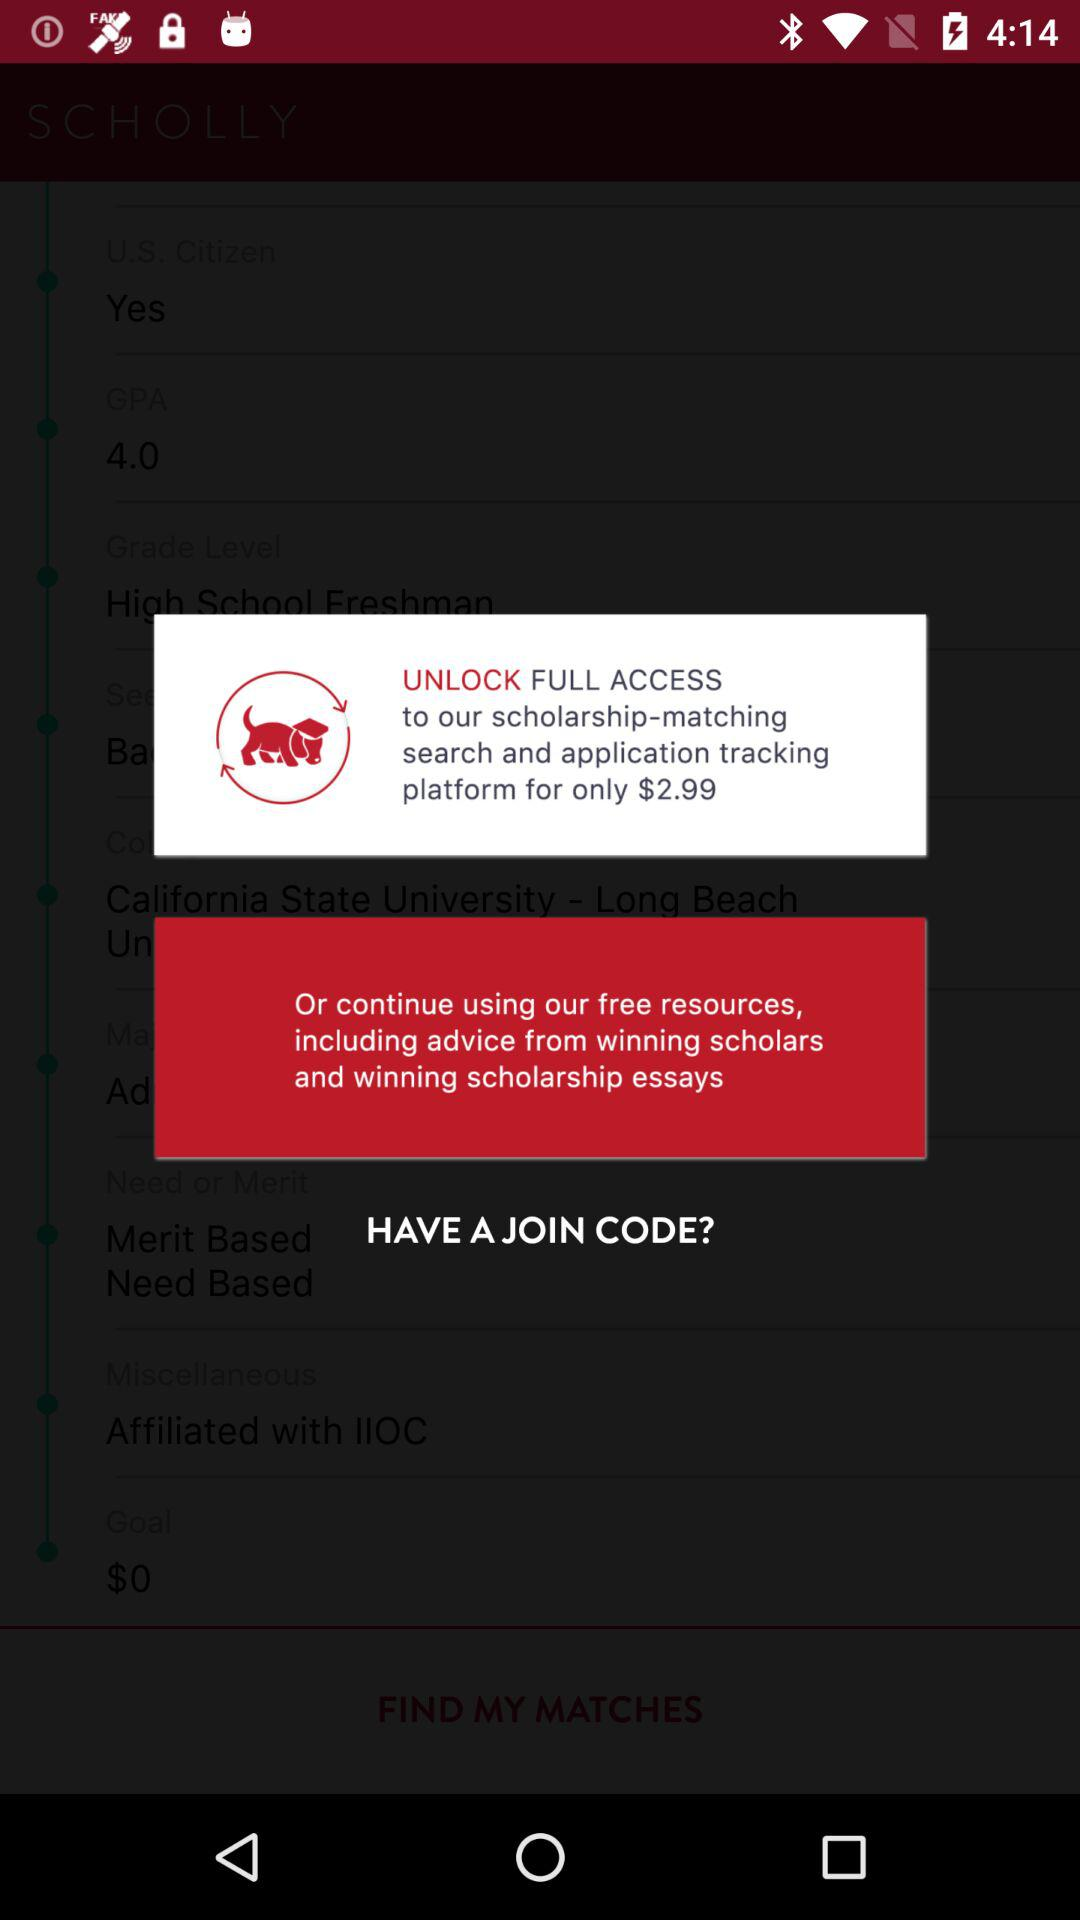What's the cost of the "scholarship-matching search and application tracking platform"? The cost is $2.99. 